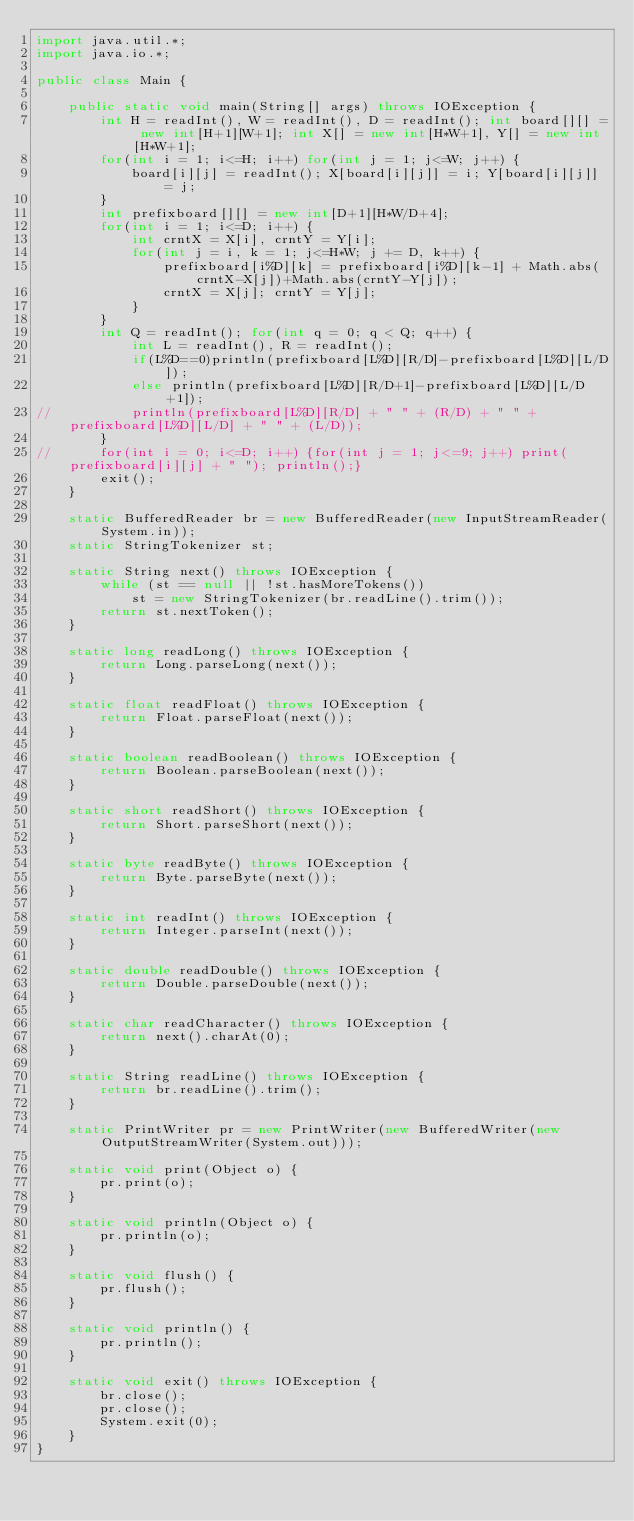Convert code to text. <code><loc_0><loc_0><loc_500><loc_500><_Java_>import java.util.*;
import java.io.*;

public class Main {

	public static void main(String[] args) throws IOException {
		int H = readInt(), W = readInt(), D = readInt(); int board[][] = new int[H+1][W+1]; int X[] = new int[H*W+1], Y[] = new int[H*W+1];
		for(int i = 1; i<=H; i++) for(int j = 1; j<=W; j++) {
			board[i][j] = readInt(); X[board[i][j]] = i; Y[board[i][j]] = j;
		}
		int prefixboard[][] = new int[D+1][H*W/D+4];
		for(int i = 1; i<=D; i++) {
			int crntX = X[i], crntY = Y[i]; 
			for(int j = i, k = 1; j<=H*W; j += D, k++) {
				prefixboard[i%D][k] = prefixboard[i%D][k-1] + Math.abs(crntX-X[j])+Math.abs(crntY-Y[j]);
				crntX = X[j]; crntY = Y[j];
			}
		}
		int Q = readInt(); for(int q = 0; q < Q; q++) {
			int L = readInt(), R = readInt(); 
			if(L%D==0)println(prefixboard[L%D][R/D]-prefixboard[L%D][L/D]);
			else println(prefixboard[L%D][R/D+1]-prefixboard[L%D][L/D+1]);
//			println(prefixboard[L%D][R/D] + " " + (R/D) + " " + prefixboard[L%D][L/D] + " " + (L/D));
		}
//		for(int i = 0; i<=D; i++) {for(int j = 1; j<=9; j++) print(prefixboard[i][j] + " "); println();}
		exit();
	}

	static BufferedReader br = new BufferedReader(new InputStreamReader(System.in));
	static StringTokenizer st;

	static String next() throws IOException {
		while (st == null || !st.hasMoreTokens())
			st = new StringTokenizer(br.readLine().trim());
		return st.nextToken();
	}

	static long readLong() throws IOException {
		return Long.parseLong(next());
	}

	static float readFloat() throws IOException {
		return Float.parseFloat(next());
	}

	static boolean readBoolean() throws IOException {
		return Boolean.parseBoolean(next());
	}

	static short readShort() throws IOException {
		return Short.parseShort(next());
	}

	static byte readByte() throws IOException {
		return Byte.parseByte(next());
	}

	static int readInt() throws IOException {
		return Integer.parseInt(next());
	}

	static double readDouble() throws IOException {
		return Double.parseDouble(next());
	}

	static char readCharacter() throws IOException {
		return next().charAt(0);
	}

	static String readLine() throws IOException {
		return br.readLine().trim();
	}

	static PrintWriter pr = new PrintWriter(new BufferedWriter(new OutputStreamWriter(System.out)));

	static void print(Object o) {
		pr.print(o);
	}

	static void println(Object o) {
		pr.println(o);
	}

	static void flush() {
		pr.flush();
	}

	static void println() {
		pr.println();
	}

	static void exit() throws IOException {
		br.close();
		pr.close();
		System.exit(0);
	}
}
</code> 